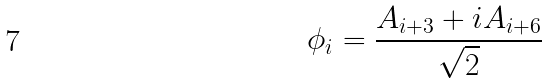<formula> <loc_0><loc_0><loc_500><loc_500>\phi _ { i } = \frac { A _ { i + 3 } + i A _ { i + 6 } } { \sqrt { 2 } }</formula> 